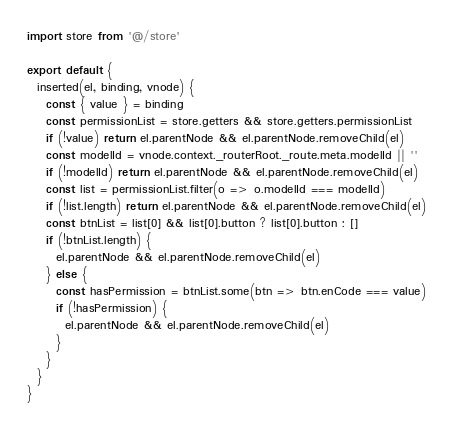<code> <loc_0><loc_0><loc_500><loc_500><_JavaScript_>import store from '@/store'

export default {
  inserted(el, binding, vnode) {
    const { value } = binding
    const permissionList = store.getters && store.getters.permissionList
    if (!value) return el.parentNode && el.parentNode.removeChild(el)
    const modelId = vnode.context._routerRoot._route.meta.modelId || ''
    if (!modelId) return el.parentNode && el.parentNode.removeChild(el)
    const list = permissionList.filter(o => o.modelId === modelId)
    if (!list.length) return el.parentNode && el.parentNode.removeChild(el)
    const btnList = list[0] && list[0].button ? list[0].button : []
    if (!btnList.length) {
      el.parentNode && el.parentNode.removeChild(el)
    } else {
      const hasPermission = btnList.some(btn => btn.enCode === value)
      if (!hasPermission) {
        el.parentNode && el.parentNode.removeChild(el)
      }
    }
  }
}</code> 